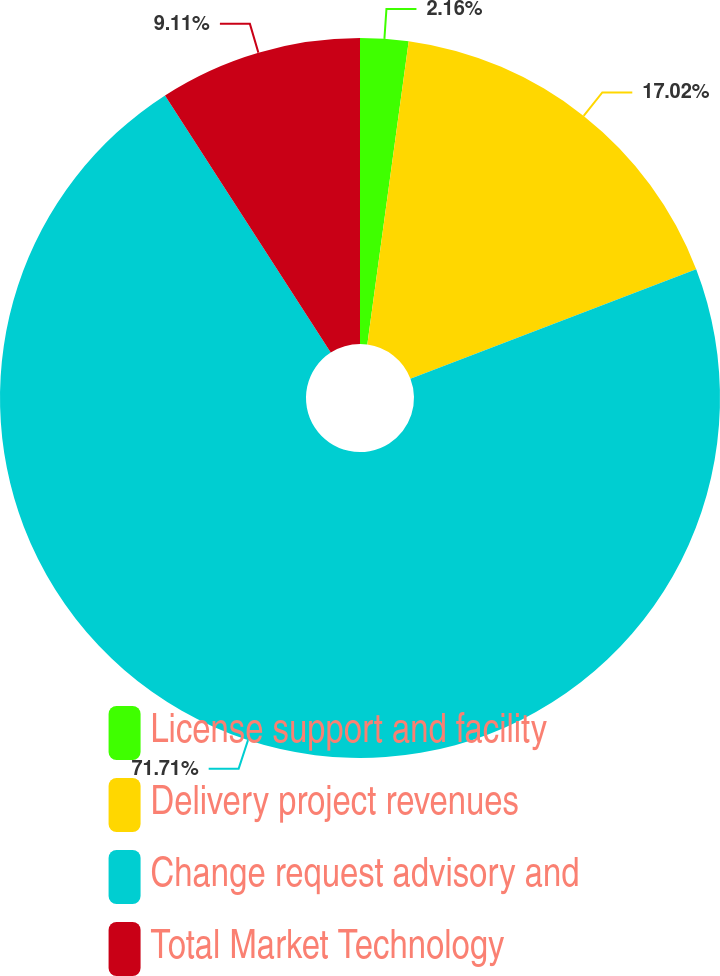<chart> <loc_0><loc_0><loc_500><loc_500><pie_chart><fcel>License support and facility<fcel>Delivery project revenues<fcel>Change request advisory and<fcel>Total Market Technology<nl><fcel>2.16%<fcel>17.02%<fcel>71.71%<fcel>9.11%<nl></chart> 